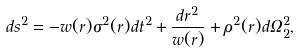<formula> <loc_0><loc_0><loc_500><loc_500>d s ^ { 2 } = - w ( r ) \sigma ^ { 2 } ( r ) d t ^ { 2 } + \frac { d r ^ { 2 } } { w ( r ) } + \rho ^ { 2 } ( r ) d \Omega _ { 2 } ^ { 2 } ,</formula> 